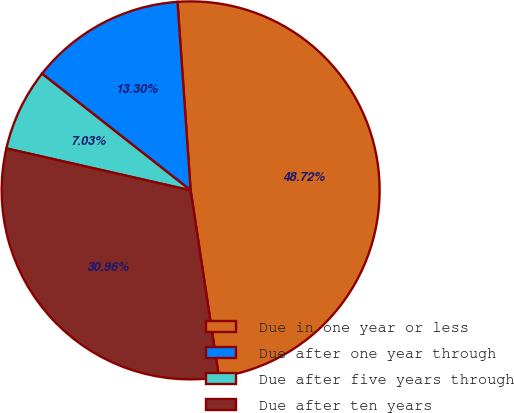<chart> <loc_0><loc_0><loc_500><loc_500><pie_chart><fcel>Due in one year or less<fcel>Due after one year through<fcel>Due after five years through<fcel>Due after ten years<nl><fcel>48.72%<fcel>13.3%<fcel>7.03%<fcel>30.96%<nl></chart> 